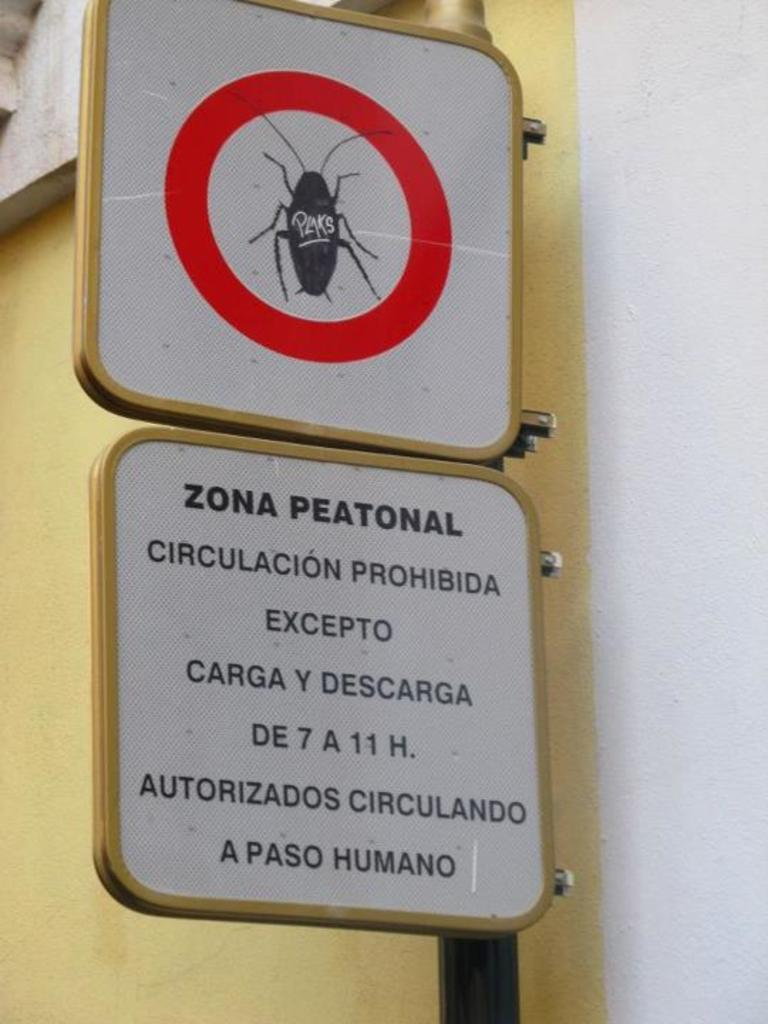What is located in the center of the image? There is a pole and sign boards in the center of the image. Can you describe the sign boards in the image? Yes, there are sign boards in the center of the image. What is visible in the background of the image? There is a wall in the background of the image. What type of fruit is hanging from the pole in the image? There is no fruit hanging from the pole in the image. How does the stitch on the sign boards help to hold them together? There is no mention of stitching on the sign boards in the image. 